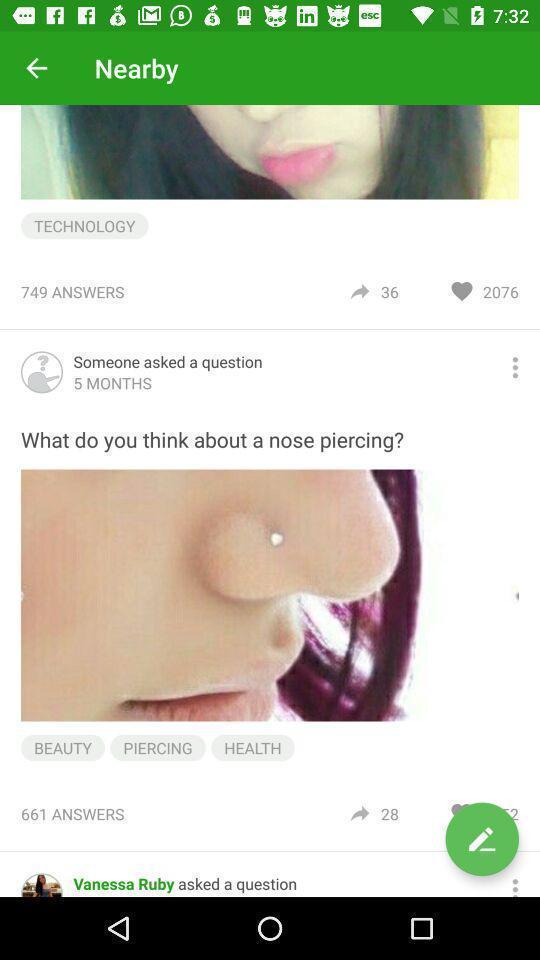What is the overall content of this screenshot? Screen displaying the page of a social app. 